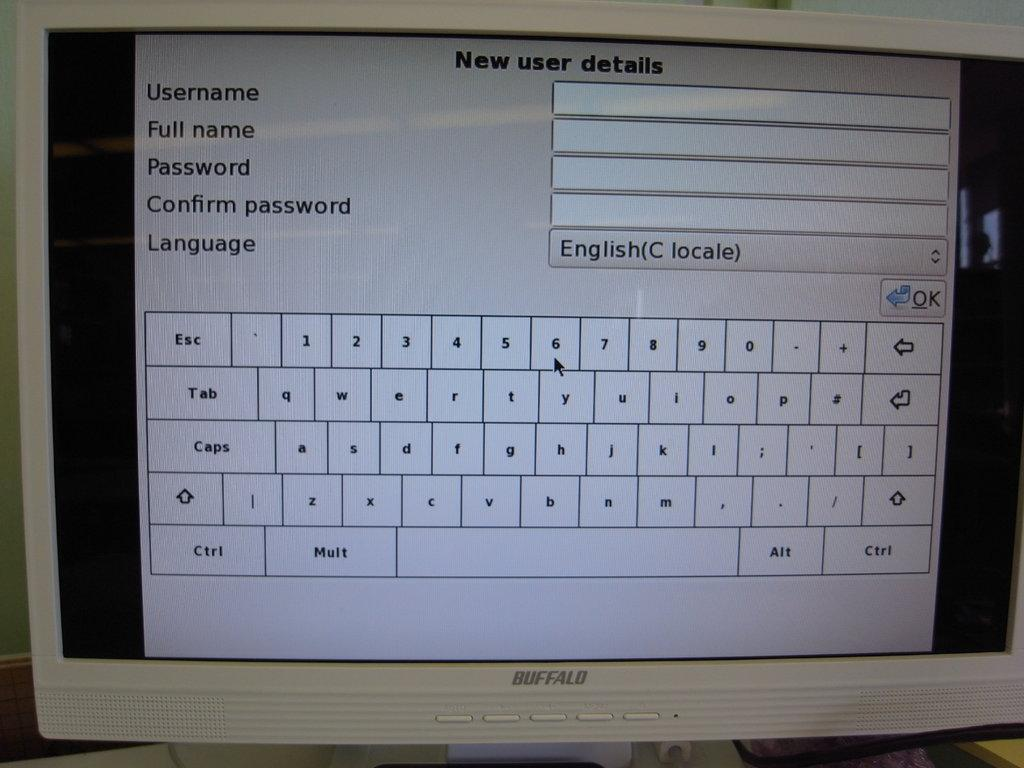Provide a one-sentence caption for the provided image. A computer monitor shows a "New user details" window. 